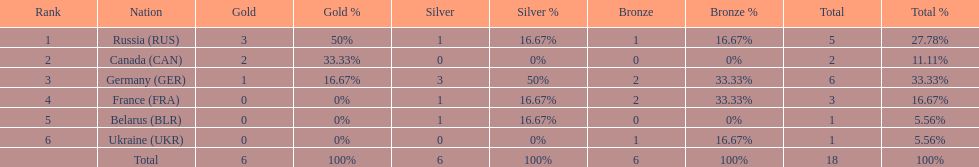What were the only 3 countries to win gold medals at the the 1994 winter olympics biathlon? Russia (RUS), Canada (CAN), Germany (GER). 